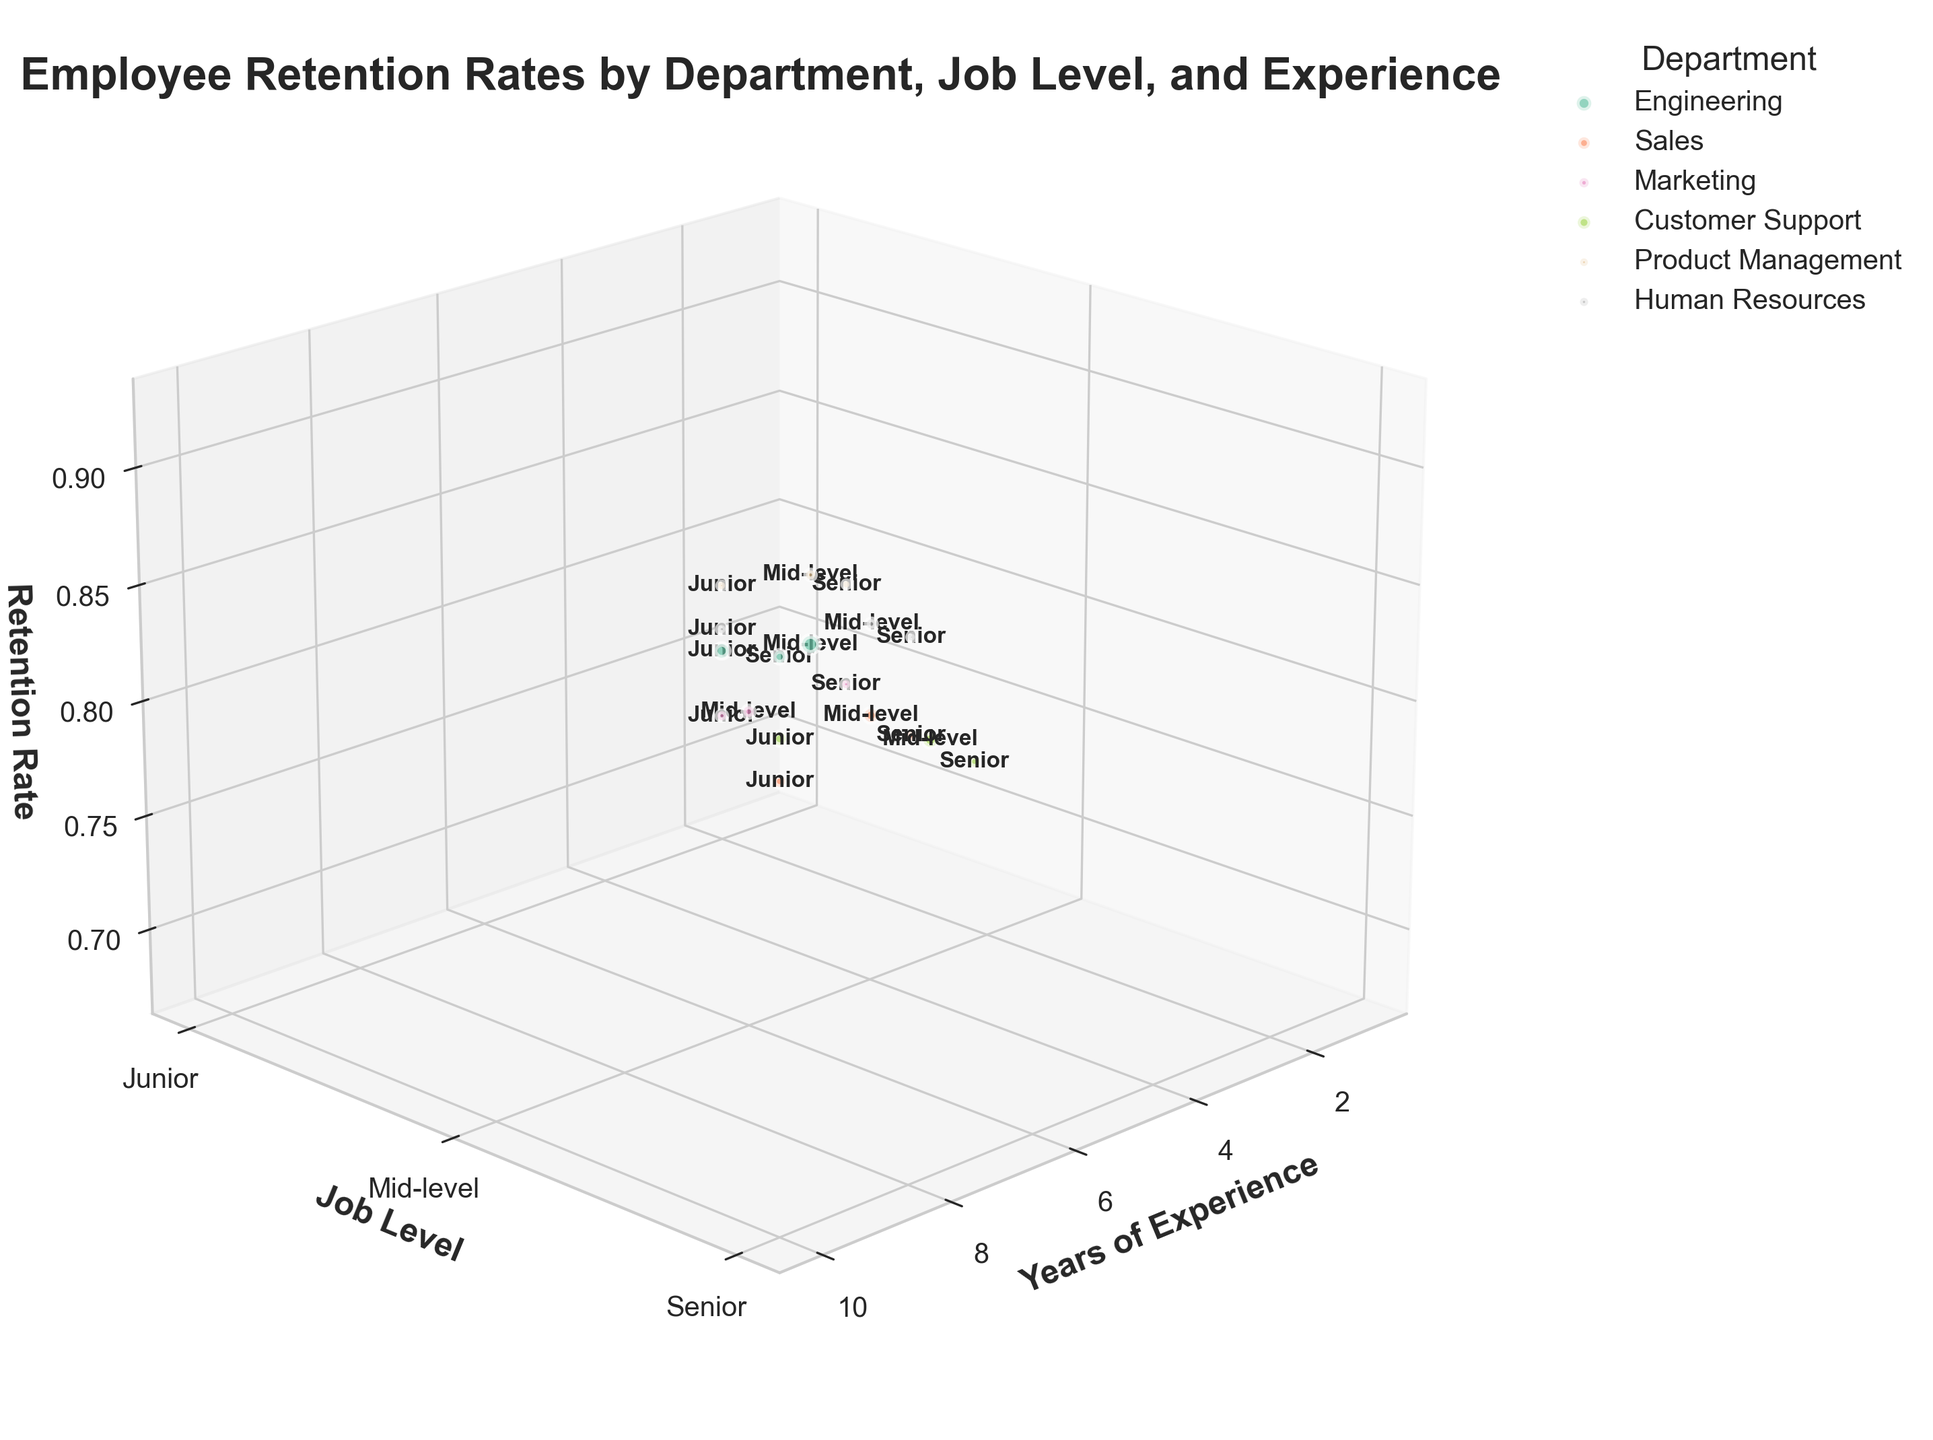What's the title of the figure? The title of a figure is usually displayed at the top and summarizing the main focus. Here, the title summarizes the variables being analyzed which are the employee retention rates by different departments, job levels, and years of experience.
Answer: Employee Retention Rates by Department, Job Level, and Experience Which department has the highest retention rate? To find the department with the highest retention rate, look for the data point with the highest z-axis value (Retention Rate) and check its color coding to identify the department.
Answer: Product Management What's the retention rate for Junior employees in the Sales department? First, locate the color representing the Sales department, then look for points labeled "Junior" on the y-axis value of 1. Check the z-axis value (Retention Rate) for that point.
Answer: 0.68 Compare the retention rates of Senior employees in Marketing and Human Resources. Which one is higher? Identify the color corresponding to Marketing and Human Resources departments. Look for points labeled "Senior" (y-axis value of 3) and compare their z-axis (Retention Rate) values.
Answer: Human Resources Which department has the most number of data points on the graph? Count the number of bubbles (data points) for each department by their unique colors and compare the counts.
Answer: Engineering How many Mid-level employees are in the Customer Support department? Identify the bubble representing Mid-level employees in Customer Support (color-specific and y-axis value of 2), then refer to the bubble size or count information.
Answer: 130 Which department has the lowest retention rate among Senior employees? Look for points labeled "Senior" on the y-axis value of 3 and compare the z-axis values across all departments to find the lowest value and its corresponding department.
Answer: Sales Name the job level with the highest retention rate in the Engineering department. Identify the points representing Engineering (specific color), compare retention rates among bubbles with y-axis values of 1 (Junior), 2 (Mid-level), and 3 (Senior) and find the highest z-axis value.
Answer: Senior 